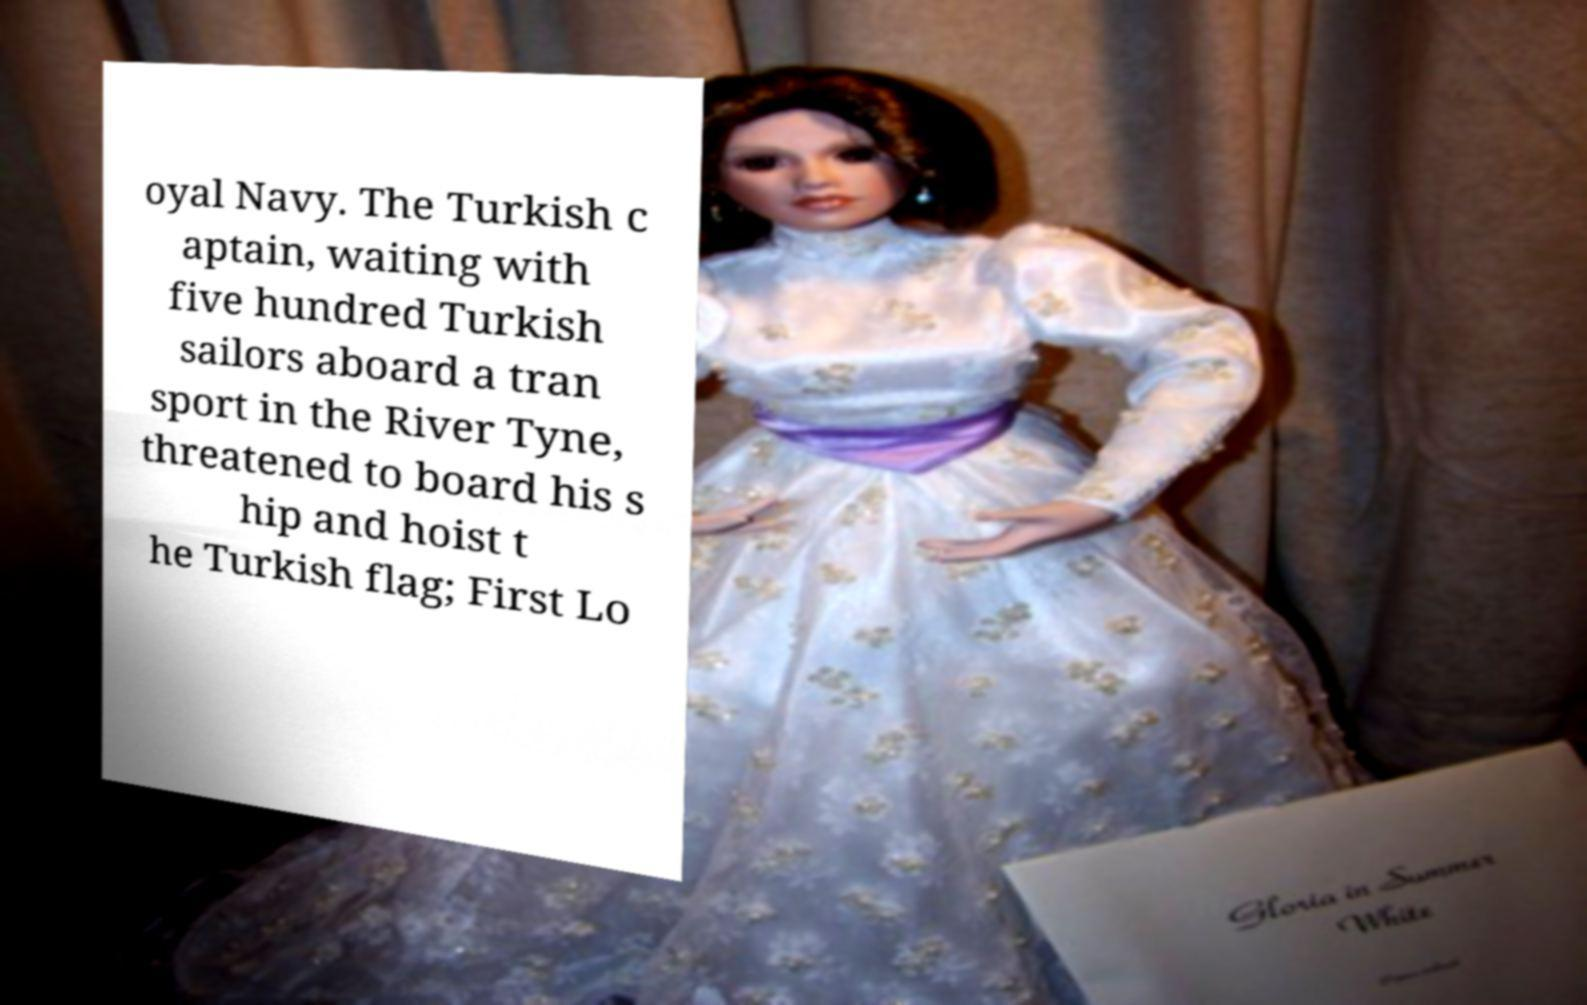Could you extract and type out the text from this image? oyal Navy. The Turkish c aptain, waiting with five hundred Turkish sailors aboard a tran sport in the River Tyne, threatened to board his s hip and hoist t he Turkish flag; First Lo 